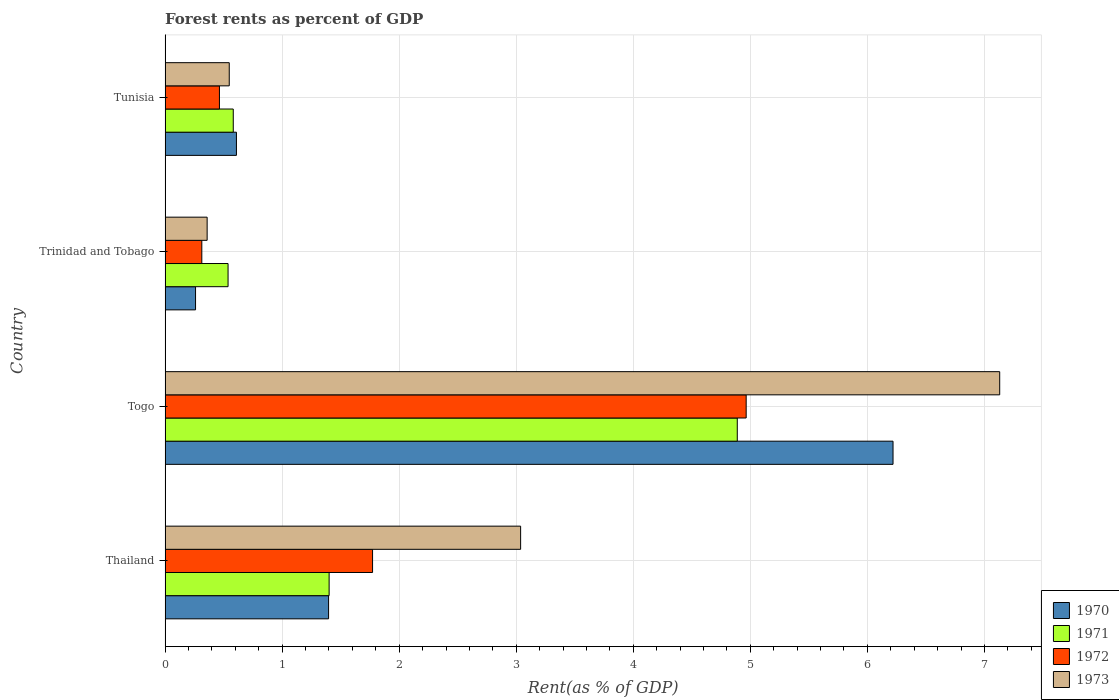How many different coloured bars are there?
Make the answer very short. 4. How many groups of bars are there?
Offer a terse response. 4. Are the number of bars per tick equal to the number of legend labels?
Your response must be concise. Yes. Are the number of bars on each tick of the Y-axis equal?
Make the answer very short. Yes. How many bars are there on the 4th tick from the top?
Offer a very short reply. 4. How many bars are there on the 1st tick from the bottom?
Provide a succinct answer. 4. What is the label of the 2nd group of bars from the top?
Provide a short and direct response. Trinidad and Tobago. What is the forest rent in 1970 in Togo?
Make the answer very short. 6.22. Across all countries, what is the maximum forest rent in 1970?
Your answer should be compact. 6.22. Across all countries, what is the minimum forest rent in 1973?
Offer a very short reply. 0.36. In which country was the forest rent in 1970 maximum?
Provide a short and direct response. Togo. In which country was the forest rent in 1973 minimum?
Make the answer very short. Trinidad and Tobago. What is the total forest rent in 1971 in the graph?
Offer a terse response. 7.41. What is the difference between the forest rent in 1973 in Togo and that in Tunisia?
Provide a succinct answer. 6.58. What is the difference between the forest rent in 1973 in Togo and the forest rent in 1972 in Trinidad and Tobago?
Provide a succinct answer. 6.82. What is the average forest rent in 1973 per country?
Make the answer very short. 2.77. What is the difference between the forest rent in 1973 and forest rent in 1970 in Thailand?
Ensure brevity in your answer.  1.64. What is the ratio of the forest rent in 1973 in Thailand to that in Togo?
Your answer should be compact. 0.43. What is the difference between the highest and the second highest forest rent in 1972?
Your response must be concise. 3.19. What is the difference between the highest and the lowest forest rent in 1973?
Offer a very short reply. 6.77. Is the sum of the forest rent in 1971 in Thailand and Tunisia greater than the maximum forest rent in 1970 across all countries?
Your response must be concise. No. Is it the case that in every country, the sum of the forest rent in 1973 and forest rent in 1971 is greater than the sum of forest rent in 1970 and forest rent in 1972?
Your answer should be very brief. Yes. What does the 2nd bar from the bottom in Tunisia represents?
Your response must be concise. 1971. Is it the case that in every country, the sum of the forest rent in 1971 and forest rent in 1973 is greater than the forest rent in 1970?
Your response must be concise. Yes. How many bars are there?
Give a very brief answer. 16. How many countries are there in the graph?
Ensure brevity in your answer.  4. What is the difference between two consecutive major ticks on the X-axis?
Make the answer very short. 1. Does the graph contain grids?
Provide a short and direct response. Yes. Where does the legend appear in the graph?
Your answer should be very brief. Bottom right. How are the legend labels stacked?
Provide a short and direct response. Vertical. What is the title of the graph?
Provide a succinct answer. Forest rents as percent of GDP. Does "2004" appear as one of the legend labels in the graph?
Ensure brevity in your answer.  No. What is the label or title of the X-axis?
Offer a very short reply. Rent(as % of GDP). What is the label or title of the Y-axis?
Make the answer very short. Country. What is the Rent(as % of GDP) in 1970 in Thailand?
Your response must be concise. 1.4. What is the Rent(as % of GDP) in 1971 in Thailand?
Give a very brief answer. 1.4. What is the Rent(as % of GDP) in 1972 in Thailand?
Your answer should be very brief. 1.77. What is the Rent(as % of GDP) in 1973 in Thailand?
Ensure brevity in your answer.  3.04. What is the Rent(as % of GDP) in 1970 in Togo?
Provide a short and direct response. 6.22. What is the Rent(as % of GDP) of 1971 in Togo?
Offer a very short reply. 4.89. What is the Rent(as % of GDP) of 1972 in Togo?
Offer a very short reply. 4.96. What is the Rent(as % of GDP) of 1973 in Togo?
Offer a terse response. 7.13. What is the Rent(as % of GDP) of 1970 in Trinidad and Tobago?
Keep it short and to the point. 0.26. What is the Rent(as % of GDP) in 1971 in Trinidad and Tobago?
Your answer should be very brief. 0.54. What is the Rent(as % of GDP) of 1972 in Trinidad and Tobago?
Offer a terse response. 0.31. What is the Rent(as % of GDP) of 1973 in Trinidad and Tobago?
Ensure brevity in your answer.  0.36. What is the Rent(as % of GDP) of 1970 in Tunisia?
Give a very brief answer. 0.61. What is the Rent(as % of GDP) of 1971 in Tunisia?
Give a very brief answer. 0.58. What is the Rent(as % of GDP) of 1972 in Tunisia?
Make the answer very short. 0.46. What is the Rent(as % of GDP) of 1973 in Tunisia?
Your response must be concise. 0.55. Across all countries, what is the maximum Rent(as % of GDP) in 1970?
Make the answer very short. 6.22. Across all countries, what is the maximum Rent(as % of GDP) in 1971?
Your answer should be very brief. 4.89. Across all countries, what is the maximum Rent(as % of GDP) of 1972?
Provide a succinct answer. 4.96. Across all countries, what is the maximum Rent(as % of GDP) in 1973?
Provide a short and direct response. 7.13. Across all countries, what is the minimum Rent(as % of GDP) in 1970?
Your answer should be compact. 0.26. Across all countries, what is the minimum Rent(as % of GDP) in 1971?
Offer a terse response. 0.54. Across all countries, what is the minimum Rent(as % of GDP) of 1972?
Offer a terse response. 0.31. Across all countries, what is the minimum Rent(as % of GDP) in 1973?
Provide a succinct answer. 0.36. What is the total Rent(as % of GDP) in 1970 in the graph?
Your answer should be compact. 8.49. What is the total Rent(as % of GDP) of 1971 in the graph?
Give a very brief answer. 7.41. What is the total Rent(as % of GDP) in 1972 in the graph?
Make the answer very short. 7.51. What is the total Rent(as % of GDP) of 1973 in the graph?
Offer a terse response. 11.08. What is the difference between the Rent(as % of GDP) of 1970 in Thailand and that in Togo?
Provide a succinct answer. -4.82. What is the difference between the Rent(as % of GDP) in 1971 in Thailand and that in Togo?
Offer a very short reply. -3.49. What is the difference between the Rent(as % of GDP) in 1972 in Thailand and that in Togo?
Ensure brevity in your answer.  -3.19. What is the difference between the Rent(as % of GDP) in 1973 in Thailand and that in Togo?
Keep it short and to the point. -4.09. What is the difference between the Rent(as % of GDP) of 1970 in Thailand and that in Trinidad and Tobago?
Ensure brevity in your answer.  1.14. What is the difference between the Rent(as % of GDP) of 1971 in Thailand and that in Trinidad and Tobago?
Your response must be concise. 0.86. What is the difference between the Rent(as % of GDP) of 1972 in Thailand and that in Trinidad and Tobago?
Make the answer very short. 1.46. What is the difference between the Rent(as % of GDP) in 1973 in Thailand and that in Trinidad and Tobago?
Offer a terse response. 2.68. What is the difference between the Rent(as % of GDP) of 1970 in Thailand and that in Tunisia?
Give a very brief answer. 0.79. What is the difference between the Rent(as % of GDP) in 1971 in Thailand and that in Tunisia?
Your response must be concise. 0.82. What is the difference between the Rent(as % of GDP) of 1972 in Thailand and that in Tunisia?
Provide a succinct answer. 1.31. What is the difference between the Rent(as % of GDP) of 1973 in Thailand and that in Tunisia?
Offer a very short reply. 2.49. What is the difference between the Rent(as % of GDP) of 1970 in Togo and that in Trinidad and Tobago?
Provide a short and direct response. 5.96. What is the difference between the Rent(as % of GDP) of 1971 in Togo and that in Trinidad and Tobago?
Keep it short and to the point. 4.35. What is the difference between the Rent(as % of GDP) of 1972 in Togo and that in Trinidad and Tobago?
Your answer should be compact. 4.65. What is the difference between the Rent(as % of GDP) in 1973 in Togo and that in Trinidad and Tobago?
Offer a very short reply. 6.77. What is the difference between the Rent(as % of GDP) of 1970 in Togo and that in Tunisia?
Keep it short and to the point. 5.61. What is the difference between the Rent(as % of GDP) in 1971 in Togo and that in Tunisia?
Offer a very short reply. 4.31. What is the difference between the Rent(as % of GDP) of 1972 in Togo and that in Tunisia?
Provide a succinct answer. 4.5. What is the difference between the Rent(as % of GDP) of 1973 in Togo and that in Tunisia?
Offer a terse response. 6.58. What is the difference between the Rent(as % of GDP) of 1970 in Trinidad and Tobago and that in Tunisia?
Offer a very short reply. -0.35. What is the difference between the Rent(as % of GDP) of 1971 in Trinidad and Tobago and that in Tunisia?
Make the answer very short. -0.04. What is the difference between the Rent(as % of GDP) in 1972 in Trinidad and Tobago and that in Tunisia?
Offer a terse response. -0.15. What is the difference between the Rent(as % of GDP) in 1973 in Trinidad and Tobago and that in Tunisia?
Your answer should be very brief. -0.19. What is the difference between the Rent(as % of GDP) in 1970 in Thailand and the Rent(as % of GDP) in 1971 in Togo?
Ensure brevity in your answer.  -3.49. What is the difference between the Rent(as % of GDP) of 1970 in Thailand and the Rent(as % of GDP) of 1972 in Togo?
Your answer should be compact. -3.57. What is the difference between the Rent(as % of GDP) in 1970 in Thailand and the Rent(as % of GDP) in 1973 in Togo?
Give a very brief answer. -5.73. What is the difference between the Rent(as % of GDP) of 1971 in Thailand and the Rent(as % of GDP) of 1972 in Togo?
Provide a succinct answer. -3.56. What is the difference between the Rent(as % of GDP) in 1971 in Thailand and the Rent(as % of GDP) in 1973 in Togo?
Your response must be concise. -5.73. What is the difference between the Rent(as % of GDP) of 1972 in Thailand and the Rent(as % of GDP) of 1973 in Togo?
Ensure brevity in your answer.  -5.36. What is the difference between the Rent(as % of GDP) of 1970 in Thailand and the Rent(as % of GDP) of 1971 in Trinidad and Tobago?
Provide a succinct answer. 0.86. What is the difference between the Rent(as % of GDP) in 1970 in Thailand and the Rent(as % of GDP) in 1972 in Trinidad and Tobago?
Your answer should be compact. 1.08. What is the difference between the Rent(as % of GDP) in 1970 in Thailand and the Rent(as % of GDP) in 1973 in Trinidad and Tobago?
Provide a short and direct response. 1.04. What is the difference between the Rent(as % of GDP) in 1971 in Thailand and the Rent(as % of GDP) in 1972 in Trinidad and Tobago?
Offer a very short reply. 1.09. What is the difference between the Rent(as % of GDP) in 1971 in Thailand and the Rent(as % of GDP) in 1973 in Trinidad and Tobago?
Ensure brevity in your answer.  1.04. What is the difference between the Rent(as % of GDP) in 1972 in Thailand and the Rent(as % of GDP) in 1973 in Trinidad and Tobago?
Offer a very short reply. 1.41. What is the difference between the Rent(as % of GDP) in 1970 in Thailand and the Rent(as % of GDP) in 1971 in Tunisia?
Offer a very short reply. 0.81. What is the difference between the Rent(as % of GDP) of 1970 in Thailand and the Rent(as % of GDP) of 1972 in Tunisia?
Keep it short and to the point. 0.93. What is the difference between the Rent(as % of GDP) of 1970 in Thailand and the Rent(as % of GDP) of 1973 in Tunisia?
Your answer should be compact. 0.85. What is the difference between the Rent(as % of GDP) in 1971 in Thailand and the Rent(as % of GDP) in 1972 in Tunisia?
Make the answer very short. 0.94. What is the difference between the Rent(as % of GDP) of 1971 in Thailand and the Rent(as % of GDP) of 1973 in Tunisia?
Make the answer very short. 0.85. What is the difference between the Rent(as % of GDP) in 1972 in Thailand and the Rent(as % of GDP) in 1973 in Tunisia?
Offer a terse response. 1.22. What is the difference between the Rent(as % of GDP) in 1970 in Togo and the Rent(as % of GDP) in 1971 in Trinidad and Tobago?
Ensure brevity in your answer.  5.68. What is the difference between the Rent(as % of GDP) in 1970 in Togo and the Rent(as % of GDP) in 1972 in Trinidad and Tobago?
Provide a succinct answer. 5.91. What is the difference between the Rent(as % of GDP) of 1970 in Togo and the Rent(as % of GDP) of 1973 in Trinidad and Tobago?
Offer a terse response. 5.86. What is the difference between the Rent(as % of GDP) of 1971 in Togo and the Rent(as % of GDP) of 1972 in Trinidad and Tobago?
Offer a terse response. 4.57. What is the difference between the Rent(as % of GDP) of 1971 in Togo and the Rent(as % of GDP) of 1973 in Trinidad and Tobago?
Make the answer very short. 4.53. What is the difference between the Rent(as % of GDP) in 1972 in Togo and the Rent(as % of GDP) in 1973 in Trinidad and Tobago?
Provide a succinct answer. 4.61. What is the difference between the Rent(as % of GDP) of 1970 in Togo and the Rent(as % of GDP) of 1971 in Tunisia?
Give a very brief answer. 5.64. What is the difference between the Rent(as % of GDP) in 1970 in Togo and the Rent(as % of GDP) in 1972 in Tunisia?
Offer a very short reply. 5.75. What is the difference between the Rent(as % of GDP) of 1970 in Togo and the Rent(as % of GDP) of 1973 in Tunisia?
Your answer should be very brief. 5.67. What is the difference between the Rent(as % of GDP) in 1971 in Togo and the Rent(as % of GDP) in 1972 in Tunisia?
Offer a very short reply. 4.42. What is the difference between the Rent(as % of GDP) in 1971 in Togo and the Rent(as % of GDP) in 1973 in Tunisia?
Provide a short and direct response. 4.34. What is the difference between the Rent(as % of GDP) of 1972 in Togo and the Rent(as % of GDP) of 1973 in Tunisia?
Your response must be concise. 4.42. What is the difference between the Rent(as % of GDP) in 1970 in Trinidad and Tobago and the Rent(as % of GDP) in 1971 in Tunisia?
Keep it short and to the point. -0.32. What is the difference between the Rent(as % of GDP) of 1970 in Trinidad and Tobago and the Rent(as % of GDP) of 1972 in Tunisia?
Your answer should be very brief. -0.2. What is the difference between the Rent(as % of GDP) in 1970 in Trinidad and Tobago and the Rent(as % of GDP) in 1973 in Tunisia?
Provide a short and direct response. -0.29. What is the difference between the Rent(as % of GDP) of 1971 in Trinidad and Tobago and the Rent(as % of GDP) of 1972 in Tunisia?
Make the answer very short. 0.07. What is the difference between the Rent(as % of GDP) of 1971 in Trinidad and Tobago and the Rent(as % of GDP) of 1973 in Tunisia?
Keep it short and to the point. -0.01. What is the difference between the Rent(as % of GDP) of 1972 in Trinidad and Tobago and the Rent(as % of GDP) of 1973 in Tunisia?
Make the answer very short. -0.23. What is the average Rent(as % of GDP) of 1970 per country?
Make the answer very short. 2.12. What is the average Rent(as % of GDP) of 1971 per country?
Provide a short and direct response. 1.85. What is the average Rent(as % of GDP) of 1972 per country?
Your answer should be compact. 1.88. What is the average Rent(as % of GDP) in 1973 per country?
Make the answer very short. 2.77. What is the difference between the Rent(as % of GDP) of 1970 and Rent(as % of GDP) of 1971 in Thailand?
Offer a very short reply. -0. What is the difference between the Rent(as % of GDP) in 1970 and Rent(as % of GDP) in 1972 in Thailand?
Give a very brief answer. -0.38. What is the difference between the Rent(as % of GDP) of 1970 and Rent(as % of GDP) of 1973 in Thailand?
Your response must be concise. -1.64. What is the difference between the Rent(as % of GDP) in 1971 and Rent(as % of GDP) in 1972 in Thailand?
Your answer should be very brief. -0.37. What is the difference between the Rent(as % of GDP) in 1971 and Rent(as % of GDP) in 1973 in Thailand?
Your answer should be very brief. -1.64. What is the difference between the Rent(as % of GDP) in 1972 and Rent(as % of GDP) in 1973 in Thailand?
Provide a succinct answer. -1.26. What is the difference between the Rent(as % of GDP) of 1970 and Rent(as % of GDP) of 1971 in Togo?
Make the answer very short. 1.33. What is the difference between the Rent(as % of GDP) in 1970 and Rent(as % of GDP) in 1972 in Togo?
Your answer should be very brief. 1.25. What is the difference between the Rent(as % of GDP) in 1970 and Rent(as % of GDP) in 1973 in Togo?
Your response must be concise. -0.91. What is the difference between the Rent(as % of GDP) in 1971 and Rent(as % of GDP) in 1972 in Togo?
Make the answer very short. -0.08. What is the difference between the Rent(as % of GDP) of 1971 and Rent(as % of GDP) of 1973 in Togo?
Your answer should be very brief. -2.24. What is the difference between the Rent(as % of GDP) in 1972 and Rent(as % of GDP) in 1973 in Togo?
Give a very brief answer. -2.17. What is the difference between the Rent(as % of GDP) in 1970 and Rent(as % of GDP) in 1971 in Trinidad and Tobago?
Keep it short and to the point. -0.28. What is the difference between the Rent(as % of GDP) of 1970 and Rent(as % of GDP) of 1972 in Trinidad and Tobago?
Offer a very short reply. -0.05. What is the difference between the Rent(as % of GDP) of 1970 and Rent(as % of GDP) of 1973 in Trinidad and Tobago?
Your response must be concise. -0.1. What is the difference between the Rent(as % of GDP) in 1971 and Rent(as % of GDP) in 1972 in Trinidad and Tobago?
Your answer should be very brief. 0.22. What is the difference between the Rent(as % of GDP) of 1971 and Rent(as % of GDP) of 1973 in Trinidad and Tobago?
Offer a terse response. 0.18. What is the difference between the Rent(as % of GDP) of 1972 and Rent(as % of GDP) of 1973 in Trinidad and Tobago?
Offer a very short reply. -0.05. What is the difference between the Rent(as % of GDP) of 1970 and Rent(as % of GDP) of 1971 in Tunisia?
Give a very brief answer. 0.03. What is the difference between the Rent(as % of GDP) of 1970 and Rent(as % of GDP) of 1972 in Tunisia?
Offer a terse response. 0.15. What is the difference between the Rent(as % of GDP) of 1970 and Rent(as % of GDP) of 1973 in Tunisia?
Make the answer very short. 0.06. What is the difference between the Rent(as % of GDP) of 1971 and Rent(as % of GDP) of 1972 in Tunisia?
Make the answer very short. 0.12. What is the difference between the Rent(as % of GDP) of 1971 and Rent(as % of GDP) of 1973 in Tunisia?
Offer a terse response. 0.03. What is the difference between the Rent(as % of GDP) of 1972 and Rent(as % of GDP) of 1973 in Tunisia?
Provide a succinct answer. -0.08. What is the ratio of the Rent(as % of GDP) in 1970 in Thailand to that in Togo?
Give a very brief answer. 0.22. What is the ratio of the Rent(as % of GDP) in 1971 in Thailand to that in Togo?
Offer a very short reply. 0.29. What is the ratio of the Rent(as % of GDP) of 1972 in Thailand to that in Togo?
Give a very brief answer. 0.36. What is the ratio of the Rent(as % of GDP) of 1973 in Thailand to that in Togo?
Your response must be concise. 0.43. What is the ratio of the Rent(as % of GDP) in 1970 in Thailand to that in Trinidad and Tobago?
Ensure brevity in your answer.  5.37. What is the ratio of the Rent(as % of GDP) of 1971 in Thailand to that in Trinidad and Tobago?
Keep it short and to the point. 2.6. What is the ratio of the Rent(as % of GDP) of 1972 in Thailand to that in Trinidad and Tobago?
Make the answer very short. 5.65. What is the ratio of the Rent(as % of GDP) of 1973 in Thailand to that in Trinidad and Tobago?
Offer a very short reply. 8.46. What is the ratio of the Rent(as % of GDP) in 1970 in Thailand to that in Tunisia?
Give a very brief answer. 2.29. What is the ratio of the Rent(as % of GDP) of 1971 in Thailand to that in Tunisia?
Offer a terse response. 2.41. What is the ratio of the Rent(as % of GDP) in 1972 in Thailand to that in Tunisia?
Your answer should be very brief. 3.82. What is the ratio of the Rent(as % of GDP) in 1973 in Thailand to that in Tunisia?
Make the answer very short. 5.54. What is the ratio of the Rent(as % of GDP) in 1970 in Togo to that in Trinidad and Tobago?
Your answer should be compact. 23.9. What is the ratio of the Rent(as % of GDP) in 1971 in Togo to that in Trinidad and Tobago?
Provide a succinct answer. 9.09. What is the ratio of the Rent(as % of GDP) in 1972 in Togo to that in Trinidad and Tobago?
Keep it short and to the point. 15.83. What is the ratio of the Rent(as % of GDP) of 1973 in Togo to that in Trinidad and Tobago?
Provide a succinct answer. 19.85. What is the ratio of the Rent(as % of GDP) in 1970 in Togo to that in Tunisia?
Provide a succinct answer. 10.2. What is the ratio of the Rent(as % of GDP) in 1971 in Togo to that in Tunisia?
Ensure brevity in your answer.  8.39. What is the ratio of the Rent(as % of GDP) of 1972 in Togo to that in Tunisia?
Ensure brevity in your answer.  10.69. What is the ratio of the Rent(as % of GDP) in 1973 in Togo to that in Tunisia?
Keep it short and to the point. 13.01. What is the ratio of the Rent(as % of GDP) in 1970 in Trinidad and Tobago to that in Tunisia?
Give a very brief answer. 0.43. What is the ratio of the Rent(as % of GDP) of 1971 in Trinidad and Tobago to that in Tunisia?
Your response must be concise. 0.92. What is the ratio of the Rent(as % of GDP) of 1972 in Trinidad and Tobago to that in Tunisia?
Your response must be concise. 0.68. What is the ratio of the Rent(as % of GDP) of 1973 in Trinidad and Tobago to that in Tunisia?
Your answer should be very brief. 0.66. What is the difference between the highest and the second highest Rent(as % of GDP) of 1970?
Provide a short and direct response. 4.82. What is the difference between the highest and the second highest Rent(as % of GDP) in 1971?
Your answer should be very brief. 3.49. What is the difference between the highest and the second highest Rent(as % of GDP) in 1972?
Give a very brief answer. 3.19. What is the difference between the highest and the second highest Rent(as % of GDP) of 1973?
Provide a short and direct response. 4.09. What is the difference between the highest and the lowest Rent(as % of GDP) in 1970?
Keep it short and to the point. 5.96. What is the difference between the highest and the lowest Rent(as % of GDP) in 1971?
Provide a succinct answer. 4.35. What is the difference between the highest and the lowest Rent(as % of GDP) in 1972?
Make the answer very short. 4.65. What is the difference between the highest and the lowest Rent(as % of GDP) in 1973?
Make the answer very short. 6.77. 